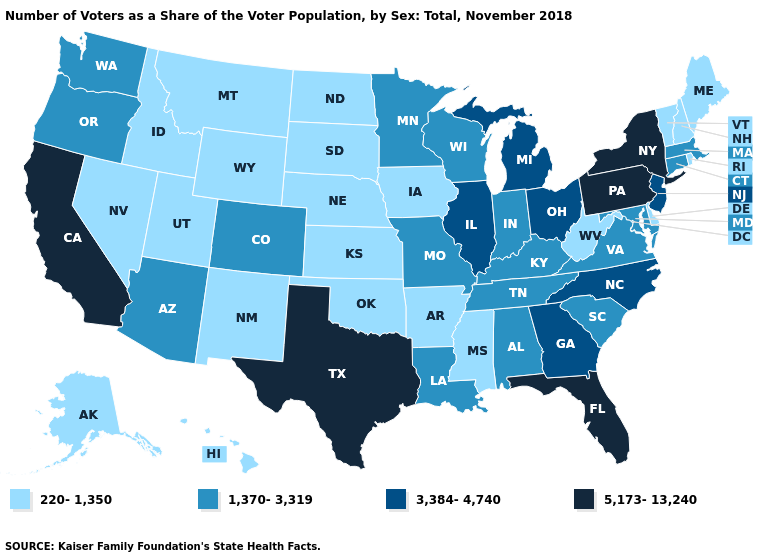How many symbols are there in the legend?
Give a very brief answer. 4. Name the states that have a value in the range 1,370-3,319?
Be succinct. Alabama, Arizona, Colorado, Connecticut, Indiana, Kentucky, Louisiana, Maryland, Massachusetts, Minnesota, Missouri, Oregon, South Carolina, Tennessee, Virginia, Washington, Wisconsin. What is the value of New Jersey?
Be succinct. 3,384-4,740. Does Texas have the highest value in the South?
Short answer required. Yes. What is the value of Rhode Island?
Write a very short answer. 220-1,350. Does Missouri have the highest value in the USA?
Concise answer only. No. What is the lowest value in the South?
Be succinct. 220-1,350. How many symbols are there in the legend?
Be succinct. 4. What is the lowest value in states that border West Virginia?
Give a very brief answer. 1,370-3,319. What is the lowest value in states that border New York?
Give a very brief answer. 220-1,350. Does Michigan have the lowest value in the MidWest?
Concise answer only. No. Does Vermont have the lowest value in the USA?
Be succinct. Yes. Name the states that have a value in the range 1,370-3,319?
Write a very short answer. Alabama, Arizona, Colorado, Connecticut, Indiana, Kentucky, Louisiana, Maryland, Massachusetts, Minnesota, Missouri, Oregon, South Carolina, Tennessee, Virginia, Washington, Wisconsin. How many symbols are there in the legend?
Short answer required. 4. How many symbols are there in the legend?
Short answer required. 4. 